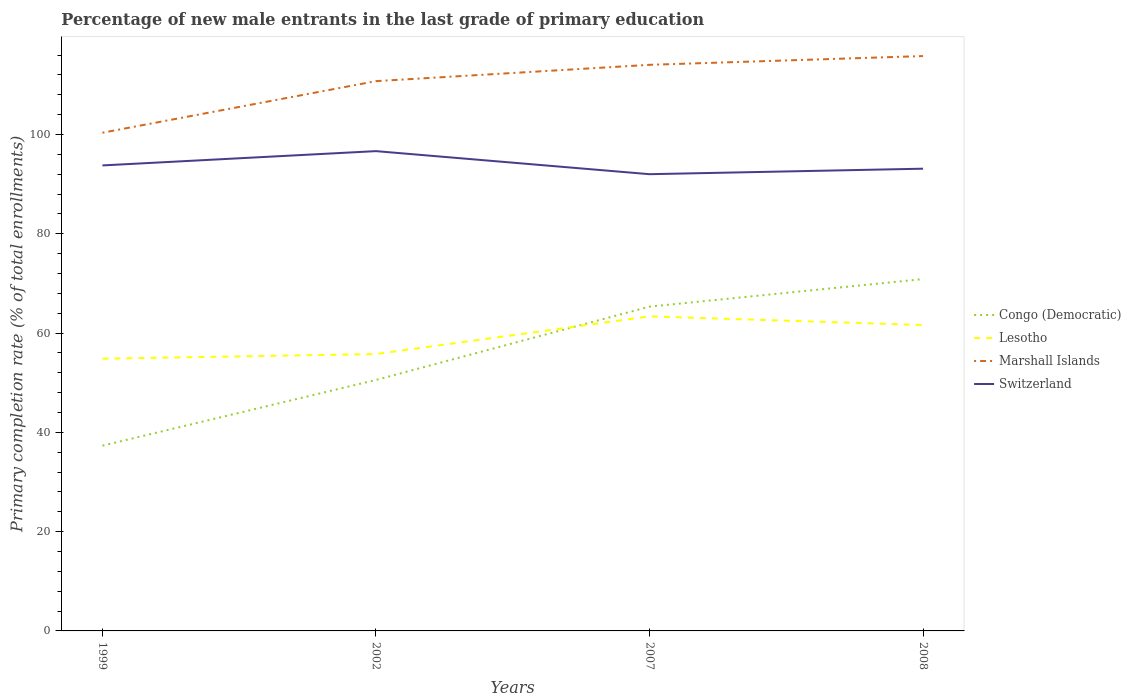How many different coloured lines are there?
Provide a succinct answer. 4. Across all years, what is the maximum percentage of new male entrants in Congo (Democratic)?
Keep it short and to the point. 37.32. What is the total percentage of new male entrants in Congo (Democratic) in the graph?
Give a very brief answer. -33.56. What is the difference between the highest and the second highest percentage of new male entrants in Congo (Democratic)?
Keep it short and to the point. 33.56. Is the percentage of new male entrants in Marshall Islands strictly greater than the percentage of new male entrants in Switzerland over the years?
Give a very brief answer. No. How many years are there in the graph?
Make the answer very short. 4. What is the difference between two consecutive major ticks on the Y-axis?
Ensure brevity in your answer.  20. Does the graph contain any zero values?
Keep it short and to the point. No. Does the graph contain grids?
Offer a very short reply. No. How are the legend labels stacked?
Keep it short and to the point. Vertical. What is the title of the graph?
Ensure brevity in your answer.  Percentage of new male entrants in the last grade of primary education. What is the label or title of the Y-axis?
Ensure brevity in your answer.  Primary completion rate (% of total enrollments). What is the Primary completion rate (% of total enrollments) in Congo (Democratic) in 1999?
Offer a terse response. 37.32. What is the Primary completion rate (% of total enrollments) in Lesotho in 1999?
Give a very brief answer. 54.84. What is the Primary completion rate (% of total enrollments) of Marshall Islands in 1999?
Provide a succinct answer. 100.36. What is the Primary completion rate (% of total enrollments) in Switzerland in 1999?
Your answer should be compact. 93.78. What is the Primary completion rate (% of total enrollments) in Congo (Democratic) in 2002?
Offer a terse response. 50.56. What is the Primary completion rate (% of total enrollments) of Lesotho in 2002?
Offer a terse response. 55.78. What is the Primary completion rate (% of total enrollments) of Marshall Islands in 2002?
Offer a very short reply. 110.76. What is the Primary completion rate (% of total enrollments) in Switzerland in 2002?
Make the answer very short. 96.66. What is the Primary completion rate (% of total enrollments) in Congo (Democratic) in 2007?
Your answer should be compact. 65.33. What is the Primary completion rate (% of total enrollments) of Lesotho in 2007?
Give a very brief answer. 63.37. What is the Primary completion rate (% of total enrollments) in Marshall Islands in 2007?
Give a very brief answer. 114.04. What is the Primary completion rate (% of total enrollments) in Switzerland in 2007?
Make the answer very short. 92.01. What is the Primary completion rate (% of total enrollments) of Congo (Democratic) in 2008?
Your response must be concise. 70.88. What is the Primary completion rate (% of total enrollments) of Lesotho in 2008?
Your answer should be very brief. 61.63. What is the Primary completion rate (% of total enrollments) in Marshall Islands in 2008?
Make the answer very short. 115.81. What is the Primary completion rate (% of total enrollments) of Switzerland in 2008?
Ensure brevity in your answer.  93.12. Across all years, what is the maximum Primary completion rate (% of total enrollments) in Congo (Democratic)?
Provide a short and direct response. 70.88. Across all years, what is the maximum Primary completion rate (% of total enrollments) in Lesotho?
Ensure brevity in your answer.  63.37. Across all years, what is the maximum Primary completion rate (% of total enrollments) of Marshall Islands?
Ensure brevity in your answer.  115.81. Across all years, what is the maximum Primary completion rate (% of total enrollments) of Switzerland?
Your answer should be very brief. 96.66. Across all years, what is the minimum Primary completion rate (% of total enrollments) in Congo (Democratic)?
Provide a short and direct response. 37.32. Across all years, what is the minimum Primary completion rate (% of total enrollments) of Lesotho?
Give a very brief answer. 54.84. Across all years, what is the minimum Primary completion rate (% of total enrollments) of Marshall Islands?
Offer a very short reply. 100.36. Across all years, what is the minimum Primary completion rate (% of total enrollments) of Switzerland?
Offer a terse response. 92.01. What is the total Primary completion rate (% of total enrollments) of Congo (Democratic) in the graph?
Keep it short and to the point. 224.09. What is the total Primary completion rate (% of total enrollments) of Lesotho in the graph?
Your response must be concise. 235.62. What is the total Primary completion rate (% of total enrollments) in Marshall Islands in the graph?
Make the answer very short. 440.97. What is the total Primary completion rate (% of total enrollments) in Switzerland in the graph?
Ensure brevity in your answer.  375.56. What is the difference between the Primary completion rate (% of total enrollments) of Congo (Democratic) in 1999 and that in 2002?
Offer a terse response. -13.24. What is the difference between the Primary completion rate (% of total enrollments) of Lesotho in 1999 and that in 2002?
Provide a succinct answer. -0.93. What is the difference between the Primary completion rate (% of total enrollments) of Marshall Islands in 1999 and that in 2002?
Give a very brief answer. -10.39. What is the difference between the Primary completion rate (% of total enrollments) in Switzerland in 1999 and that in 2002?
Provide a short and direct response. -2.88. What is the difference between the Primary completion rate (% of total enrollments) of Congo (Democratic) in 1999 and that in 2007?
Offer a very short reply. -28.01. What is the difference between the Primary completion rate (% of total enrollments) in Lesotho in 1999 and that in 2007?
Provide a succinct answer. -8.53. What is the difference between the Primary completion rate (% of total enrollments) of Marshall Islands in 1999 and that in 2007?
Offer a very short reply. -13.68. What is the difference between the Primary completion rate (% of total enrollments) in Switzerland in 1999 and that in 2007?
Provide a short and direct response. 1.77. What is the difference between the Primary completion rate (% of total enrollments) of Congo (Democratic) in 1999 and that in 2008?
Your answer should be very brief. -33.56. What is the difference between the Primary completion rate (% of total enrollments) of Lesotho in 1999 and that in 2008?
Offer a terse response. -6.78. What is the difference between the Primary completion rate (% of total enrollments) in Marshall Islands in 1999 and that in 2008?
Ensure brevity in your answer.  -15.44. What is the difference between the Primary completion rate (% of total enrollments) of Switzerland in 1999 and that in 2008?
Ensure brevity in your answer.  0.66. What is the difference between the Primary completion rate (% of total enrollments) in Congo (Democratic) in 2002 and that in 2007?
Ensure brevity in your answer.  -14.77. What is the difference between the Primary completion rate (% of total enrollments) in Lesotho in 2002 and that in 2007?
Give a very brief answer. -7.6. What is the difference between the Primary completion rate (% of total enrollments) of Marshall Islands in 2002 and that in 2007?
Your response must be concise. -3.29. What is the difference between the Primary completion rate (% of total enrollments) in Switzerland in 2002 and that in 2007?
Ensure brevity in your answer.  4.65. What is the difference between the Primary completion rate (% of total enrollments) in Congo (Democratic) in 2002 and that in 2008?
Provide a short and direct response. -20.32. What is the difference between the Primary completion rate (% of total enrollments) in Lesotho in 2002 and that in 2008?
Provide a short and direct response. -5.85. What is the difference between the Primary completion rate (% of total enrollments) of Marshall Islands in 2002 and that in 2008?
Offer a very short reply. -5.05. What is the difference between the Primary completion rate (% of total enrollments) in Switzerland in 2002 and that in 2008?
Your answer should be very brief. 3.54. What is the difference between the Primary completion rate (% of total enrollments) in Congo (Democratic) in 2007 and that in 2008?
Make the answer very short. -5.55. What is the difference between the Primary completion rate (% of total enrollments) of Lesotho in 2007 and that in 2008?
Your response must be concise. 1.75. What is the difference between the Primary completion rate (% of total enrollments) in Marshall Islands in 2007 and that in 2008?
Ensure brevity in your answer.  -1.77. What is the difference between the Primary completion rate (% of total enrollments) of Switzerland in 2007 and that in 2008?
Give a very brief answer. -1.11. What is the difference between the Primary completion rate (% of total enrollments) of Congo (Democratic) in 1999 and the Primary completion rate (% of total enrollments) of Lesotho in 2002?
Your answer should be compact. -18.45. What is the difference between the Primary completion rate (% of total enrollments) in Congo (Democratic) in 1999 and the Primary completion rate (% of total enrollments) in Marshall Islands in 2002?
Your response must be concise. -73.43. What is the difference between the Primary completion rate (% of total enrollments) of Congo (Democratic) in 1999 and the Primary completion rate (% of total enrollments) of Switzerland in 2002?
Make the answer very short. -59.33. What is the difference between the Primary completion rate (% of total enrollments) in Lesotho in 1999 and the Primary completion rate (% of total enrollments) in Marshall Islands in 2002?
Give a very brief answer. -55.91. What is the difference between the Primary completion rate (% of total enrollments) of Lesotho in 1999 and the Primary completion rate (% of total enrollments) of Switzerland in 2002?
Offer a very short reply. -41.81. What is the difference between the Primary completion rate (% of total enrollments) of Marshall Islands in 1999 and the Primary completion rate (% of total enrollments) of Switzerland in 2002?
Offer a terse response. 3.71. What is the difference between the Primary completion rate (% of total enrollments) of Congo (Democratic) in 1999 and the Primary completion rate (% of total enrollments) of Lesotho in 2007?
Provide a short and direct response. -26.05. What is the difference between the Primary completion rate (% of total enrollments) of Congo (Democratic) in 1999 and the Primary completion rate (% of total enrollments) of Marshall Islands in 2007?
Your answer should be very brief. -76.72. What is the difference between the Primary completion rate (% of total enrollments) in Congo (Democratic) in 1999 and the Primary completion rate (% of total enrollments) in Switzerland in 2007?
Make the answer very short. -54.69. What is the difference between the Primary completion rate (% of total enrollments) of Lesotho in 1999 and the Primary completion rate (% of total enrollments) of Marshall Islands in 2007?
Offer a terse response. -59.2. What is the difference between the Primary completion rate (% of total enrollments) of Lesotho in 1999 and the Primary completion rate (% of total enrollments) of Switzerland in 2007?
Provide a short and direct response. -37.17. What is the difference between the Primary completion rate (% of total enrollments) in Marshall Islands in 1999 and the Primary completion rate (% of total enrollments) in Switzerland in 2007?
Make the answer very short. 8.36. What is the difference between the Primary completion rate (% of total enrollments) in Congo (Democratic) in 1999 and the Primary completion rate (% of total enrollments) in Lesotho in 2008?
Offer a very short reply. -24.3. What is the difference between the Primary completion rate (% of total enrollments) of Congo (Democratic) in 1999 and the Primary completion rate (% of total enrollments) of Marshall Islands in 2008?
Keep it short and to the point. -78.49. What is the difference between the Primary completion rate (% of total enrollments) of Congo (Democratic) in 1999 and the Primary completion rate (% of total enrollments) of Switzerland in 2008?
Keep it short and to the point. -55.8. What is the difference between the Primary completion rate (% of total enrollments) in Lesotho in 1999 and the Primary completion rate (% of total enrollments) in Marshall Islands in 2008?
Ensure brevity in your answer.  -60.97. What is the difference between the Primary completion rate (% of total enrollments) of Lesotho in 1999 and the Primary completion rate (% of total enrollments) of Switzerland in 2008?
Your response must be concise. -38.28. What is the difference between the Primary completion rate (% of total enrollments) in Marshall Islands in 1999 and the Primary completion rate (% of total enrollments) in Switzerland in 2008?
Your answer should be compact. 7.24. What is the difference between the Primary completion rate (% of total enrollments) of Congo (Democratic) in 2002 and the Primary completion rate (% of total enrollments) of Lesotho in 2007?
Ensure brevity in your answer.  -12.81. What is the difference between the Primary completion rate (% of total enrollments) of Congo (Democratic) in 2002 and the Primary completion rate (% of total enrollments) of Marshall Islands in 2007?
Make the answer very short. -63.48. What is the difference between the Primary completion rate (% of total enrollments) in Congo (Democratic) in 2002 and the Primary completion rate (% of total enrollments) in Switzerland in 2007?
Keep it short and to the point. -41.45. What is the difference between the Primary completion rate (% of total enrollments) in Lesotho in 2002 and the Primary completion rate (% of total enrollments) in Marshall Islands in 2007?
Provide a succinct answer. -58.27. What is the difference between the Primary completion rate (% of total enrollments) in Lesotho in 2002 and the Primary completion rate (% of total enrollments) in Switzerland in 2007?
Give a very brief answer. -36.23. What is the difference between the Primary completion rate (% of total enrollments) of Marshall Islands in 2002 and the Primary completion rate (% of total enrollments) of Switzerland in 2007?
Offer a terse response. 18.75. What is the difference between the Primary completion rate (% of total enrollments) in Congo (Democratic) in 2002 and the Primary completion rate (% of total enrollments) in Lesotho in 2008?
Make the answer very short. -11.07. What is the difference between the Primary completion rate (% of total enrollments) in Congo (Democratic) in 2002 and the Primary completion rate (% of total enrollments) in Marshall Islands in 2008?
Provide a short and direct response. -65.25. What is the difference between the Primary completion rate (% of total enrollments) of Congo (Democratic) in 2002 and the Primary completion rate (% of total enrollments) of Switzerland in 2008?
Provide a succinct answer. -42.56. What is the difference between the Primary completion rate (% of total enrollments) in Lesotho in 2002 and the Primary completion rate (% of total enrollments) in Marshall Islands in 2008?
Your answer should be compact. -60.03. What is the difference between the Primary completion rate (% of total enrollments) in Lesotho in 2002 and the Primary completion rate (% of total enrollments) in Switzerland in 2008?
Your response must be concise. -37.34. What is the difference between the Primary completion rate (% of total enrollments) in Marshall Islands in 2002 and the Primary completion rate (% of total enrollments) in Switzerland in 2008?
Give a very brief answer. 17.64. What is the difference between the Primary completion rate (% of total enrollments) of Congo (Democratic) in 2007 and the Primary completion rate (% of total enrollments) of Lesotho in 2008?
Make the answer very short. 3.7. What is the difference between the Primary completion rate (% of total enrollments) of Congo (Democratic) in 2007 and the Primary completion rate (% of total enrollments) of Marshall Islands in 2008?
Give a very brief answer. -50.48. What is the difference between the Primary completion rate (% of total enrollments) of Congo (Democratic) in 2007 and the Primary completion rate (% of total enrollments) of Switzerland in 2008?
Give a very brief answer. -27.79. What is the difference between the Primary completion rate (% of total enrollments) in Lesotho in 2007 and the Primary completion rate (% of total enrollments) in Marshall Islands in 2008?
Provide a succinct answer. -52.44. What is the difference between the Primary completion rate (% of total enrollments) in Lesotho in 2007 and the Primary completion rate (% of total enrollments) in Switzerland in 2008?
Offer a very short reply. -29.75. What is the difference between the Primary completion rate (% of total enrollments) in Marshall Islands in 2007 and the Primary completion rate (% of total enrollments) in Switzerland in 2008?
Make the answer very short. 20.92. What is the average Primary completion rate (% of total enrollments) of Congo (Democratic) per year?
Your answer should be compact. 56.02. What is the average Primary completion rate (% of total enrollments) of Lesotho per year?
Your response must be concise. 58.9. What is the average Primary completion rate (% of total enrollments) in Marshall Islands per year?
Provide a short and direct response. 110.24. What is the average Primary completion rate (% of total enrollments) of Switzerland per year?
Ensure brevity in your answer.  93.89. In the year 1999, what is the difference between the Primary completion rate (% of total enrollments) of Congo (Democratic) and Primary completion rate (% of total enrollments) of Lesotho?
Keep it short and to the point. -17.52. In the year 1999, what is the difference between the Primary completion rate (% of total enrollments) in Congo (Democratic) and Primary completion rate (% of total enrollments) in Marshall Islands?
Your response must be concise. -63.04. In the year 1999, what is the difference between the Primary completion rate (% of total enrollments) of Congo (Democratic) and Primary completion rate (% of total enrollments) of Switzerland?
Your response must be concise. -56.46. In the year 1999, what is the difference between the Primary completion rate (% of total enrollments) in Lesotho and Primary completion rate (% of total enrollments) in Marshall Islands?
Offer a terse response. -45.52. In the year 1999, what is the difference between the Primary completion rate (% of total enrollments) of Lesotho and Primary completion rate (% of total enrollments) of Switzerland?
Offer a very short reply. -38.93. In the year 1999, what is the difference between the Primary completion rate (% of total enrollments) in Marshall Islands and Primary completion rate (% of total enrollments) in Switzerland?
Provide a succinct answer. 6.59. In the year 2002, what is the difference between the Primary completion rate (% of total enrollments) of Congo (Democratic) and Primary completion rate (% of total enrollments) of Lesotho?
Your answer should be very brief. -5.22. In the year 2002, what is the difference between the Primary completion rate (% of total enrollments) in Congo (Democratic) and Primary completion rate (% of total enrollments) in Marshall Islands?
Ensure brevity in your answer.  -60.2. In the year 2002, what is the difference between the Primary completion rate (% of total enrollments) of Congo (Democratic) and Primary completion rate (% of total enrollments) of Switzerland?
Keep it short and to the point. -46.1. In the year 2002, what is the difference between the Primary completion rate (% of total enrollments) of Lesotho and Primary completion rate (% of total enrollments) of Marshall Islands?
Your answer should be very brief. -54.98. In the year 2002, what is the difference between the Primary completion rate (% of total enrollments) of Lesotho and Primary completion rate (% of total enrollments) of Switzerland?
Ensure brevity in your answer.  -40.88. In the year 2002, what is the difference between the Primary completion rate (% of total enrollments) of Marshall Islands and Primary completion rate (% of total enrollments) of Switzerland?
Make the answer very short. 14.1. In the year 2007, what is the difference between the Primary completion rate (% of total enrollments) in Congo (Democratic) and Primary completion rate (% of total enrollments) in Lesotho?
Offer a very short reply. 1.96. In the year 2007, what is the difference between the Primary completion rate (% of total enrollments) in Congo (Democratic) and Primary completion rate (% of total enrollments) in Marshall Islands?
Provide a succinct answer. -48.71. In the year 2007, what is the difference between the Primary completion rate (% of total enrollments) of Congo (Democratic) and Primary completion rate (% of total enrollments) of Switzerland?
Provide a succinct answer. -26.68. In the year 2007, what is the difference between the Primary completion rate (% of total enrollments) of Lesotho and Primary completion rate (% of total enrollments) of Marshall Islands?
Give a very brief answer. -50.67. In the year 2007, what is the difference between the Primary completion rate (% of total enrollments) of Lesotho and Primary completion rate (% of total enrollments) of Switzerland?
Offer a very short reply. -28.64. In the year 2007, what is the difference between the Primary completion rate (% of total enrollments) in Marshall Islands and Primary completion rate (% of total enrollments) in Switzerland?
Give a very brief answer. 22.03. In the year 2008, what is the difference between the Primary completion rate (% of total enrollments) of Congo (Democratic) and Primary completion rate (% of total enrollments) of Lesotho?
Your answer should be very brief. 9.25. In the year 2008, what is the difference between the Primary completion rate (% of total enrollments) of Congo (Democratic) and Primary completion rate (% of total enrollments) of Marshall Islands?
Offer a terse response. -44.93. In the year 2008, what is the difference between the Primary completion rate (% of total enrollments) in Congo (Democratic) and Primary completion rate (% of total enrollments) in Switzerland?
Provide a short and direct response. -22.24. In the year 2008, what is the difference between the Primary completion rate (% of total enrollments) in Lesotho and Primary completion rate (% of total enrollments) in Marshall Islands?
Provide a short and direct response. -54.18. In the year 2008, what is the difference between the Primary completion rate (% of total enrollments) in Lesotho and Primary completion rate (% of total enrollments) in Switzerland?
Your answer should be very brief. -31.49. In the year 2008, what is the difference between the Primary completion rate (% of total enrollments) of Marshall Islands and Primary completion rate (% of total enrollments) of Switzerland?
Offer a very short reply. 22.69. What is the ratio of the Primary completion rate (% of total enrollments) of Congo (Democratic) in 1999 to that in 2002?
Ensure brevity in your answer.  0.74. What is the ratio of the Primary completion rate (% of total enrollments) in Lesotho in 1999 to that in 2002?
Offer a very short reply. 0.98. What is the ratio of the Primary completion rate (% of total enrollments) of Marshall Islands in 1999 to that in 2002?
Provide a succinct answer. 0.91. What is the ratio of the Primary completion rate (% of total enrollments) in Switzerland in 1999 to that in 2002?
Offer a very short reply. 0.97. What is the ratio of the Primary completion rate (% of total enrollments) in Congo (Democratic) in 1999 to that in 2007?
Keep it short and to the point. 0.57. What is the ratio of the Primary completion rate (% of total enrollments) of Lesotho in 1999 to that in 2007?
Your answer should be very brief. 0.87. What is the ratio of the Primary completion rate (% of total enrollments) in Marshall Islands in 1999 to that in 2007?
Give a very brief answer. 0.88. What is the ratio of the Primary completion rate (% of total enrollments) in Switzerland in 1999 to that in 2007?
Provide a short and direct response. 1.02. What is the ratio of the Primary completion rate (% of total enrollments) in Congo (Democratic) in 1999 to that in 2008?
Your response must be concise. 0.53. What is the ratio of the Primary completion rate (% of total enrollments) in Lesotho in 1999 to that in 2008?
Keep it short and to the point. 0.89. What is the ratio of the Primary completion rate (% of total enrollments) of Marshall Islands in 1999 to that in 2008?
Offer a terse response. 0.87. What is the ratio of the Primary completion rate (% of total enrollments) in Switzerland in 1999 to that in 2008?
Make the answer very short. 1.01. What is the ratio of the Primary completion rate (% of total enrollments) of Congo (Democratic) in 2002 to that in 2007?
Provide a short and direct response. 0.77. What is the ratio of the Primary completion rate (% of total enrollments) in Lesotho in 2002 to that in 2007?
Make the answer very short. 0.88. What is the ratio of the Primary completion rate (% of total enrollments) in Marshall Islands in 2002 to that in 2007?
Give a very brief answer. 0.97. What is the ratio of the Primary completion rate (% of total enrollments) in Switzerland in 2002 to that in 2007?
Your answer should be compact. 1.05. What is the ratio of the Primary completion rate (% of total enrollments) of Congo (Democratic) in 2002 to that in 2008?
Provide a succinct answer. 0.71. What is the ratio of the Primary completion rate (% of total enrollments) in Lesotho in 2002 to that in 2008?
Offer a very short reply. 0.91. What is the ratio of the Primary completion rate (% of total enrollments) in Marshall Islands in 2002 to that in 2008?
Give a very brief answer. 0.96. What is the ratio of the Primary completion rate (% of total enrollments) in Switzerland in 2002 to that in 2008?
Ensure brevity in your answer.  1.04. What is the ratio of the Primary completion rate (% of total enrollments) of Congo (Democratic) in 2007 to that in 2008?
Provide a short and direct response. 0.92. What is the ratio of the Primary completion rate (% of total enrollments) in Lesotho in 2007 to that in 2008?
Give a very brief answer. 1.03. What is the ratio of the Primary completion rate (% of total enrollments) in Marshall Islands in 2007 to that in 2008?
Offer a terse response. 0.98. What is the ratio of the Primary completion rate (% of total enrollments) of Switzerland in 2007 to that in 2008?
Your response must be concise. 0.99. What is the difference between the highest and the second highest Primary completion rate (% of total enrollments) of Congo (Democratic)?
Provide a short and direct response. 5.55. What is the difference between the highest and the second highest Primary completion rate (% of total enrollments) in Lesotho?
Give a very brief answer. 1.75. What is the difference between the highest and the second highest Primary completion rate (% of total enrollments) in Marshall Islands?
Your answer should be very brief. 1.77. What is the difference between the highest and the second highest Primary completion rate (% of total enrollments) in Switzerland?
Ensure brevity in your answer.  2.88. What is the difference between the highest and the lowest Primary completion rate (% of total enrollments) in Congo (Democratic)?
Offer a very short reply. 33.56. What is the difference between the highest and the lowest Primary completion rate (% of total enrollments) in Lesotho?
Your response must be concise. 8.53. What is the difference between the highest and the lowest Primary completion rate (% of total enrollments) in Marshall Islands?
Provide a succinct answer. 15.44. What is the difference between the highest and the lowest Primary completion rate (% of total enrollments) in Switzerland?
Ensure brevity in your answer.  4.65. 